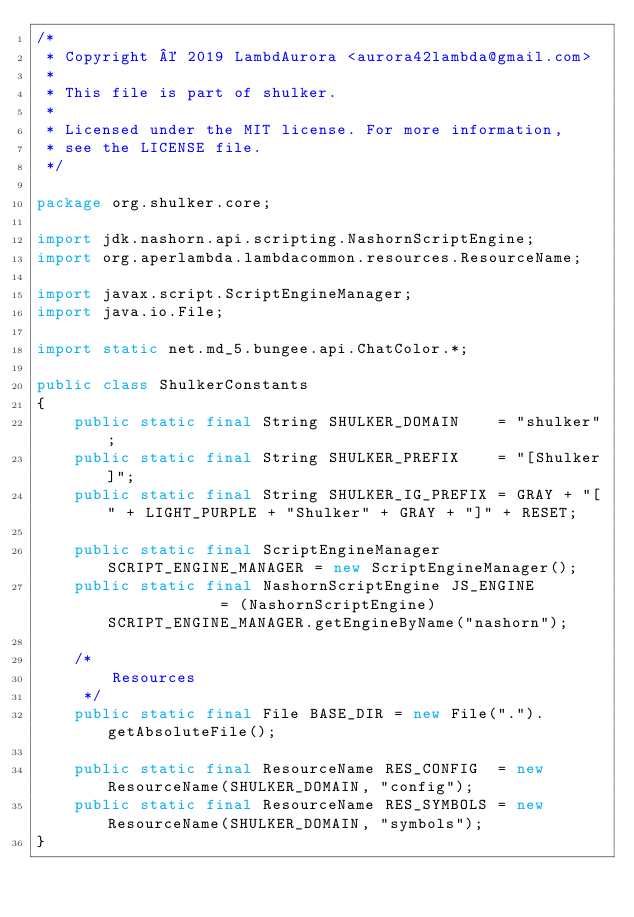Convert code to text. <code><loc_0><loc_0><loc_500><loc_500><_Java_>/*
 * Copyright © 2019 LambdAurora <aurora42lambda@gmail.com>
 *
 * This file is part of shulker.
 *
 * Licensed under the MIT license. For more information,
 * see the LICENSE file.
 */

package org.shulker.core;

import jdk.nashorn.api.scripting.NashornScriptEngine;
import org.aperlambda.lambdacommon.resources.ResourceName;

import javax.script.ScriptEngineManager;
import java.io.File;

import static net.md_5.bungee.api.ChatColor.*;

public class ShulkerConstants
{
    public static final String SHULKER_DOMAIN    = "shulker";
    public static final String SHULKER_PREFIX    = "[Shulker]";
    public static final String SHULKER_IG_PREFIX = GRAY + "[" + LIGHT_PURPLE + "Shulker" + GRAY + "]" + RESET;

    public static final ScriptEngineManager SCRIPT_ENGINE_MANAGER = new ScriptEngineManager();
    public static final NashornScriptEngine JS_ENGINE             = (NashornScriptEngine) SCRIPT_ENGINE_MANAGER.getEngineByName("nashorn");

    /*
        Resources
     */
    public static final File BASE_DIR = new File(".").getAbsoluteFile();

    public static final ResourceName RES_CONFIG  = new ResourceName(SHULKER_DOMAIN, "config");
    public static final ResourceName RES_SYMBOLS = new ResourceName(SHULKER_DOMAIN, "symbols");
}
</code> 